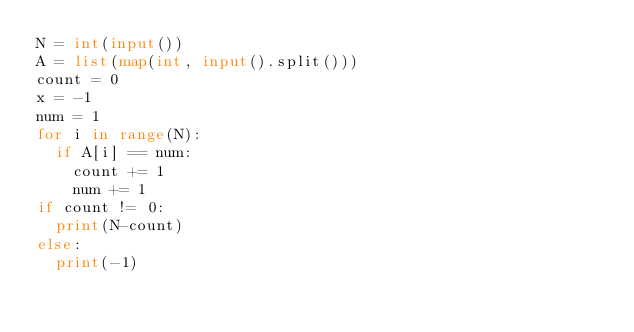<code> <loc_0><loc_0><loc_500><loc_500><_Python_>N = int(input())
A = list(map(int, input().split()))
count = 0
x = -1
num = 1
for i in range(N):
  if A[i] == num:
    count += 1
    num += 1
if count != 0:
  print(N-count)
else:
  print(-1)
</code> 